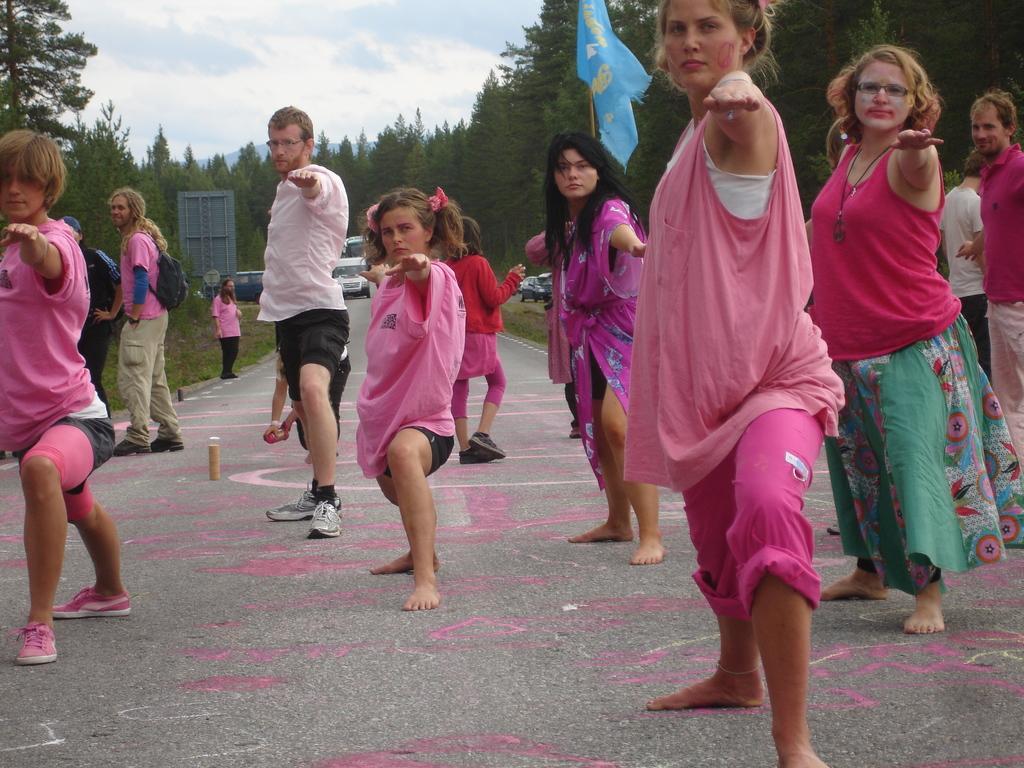Describe this image in one or two sentences. In this image, we can see a group of people are standing on the road. Left side of the image, a person is wearing a backpack. Background we can see so many trees, vehicles, board, flag. Top of the image, there is a sky. 